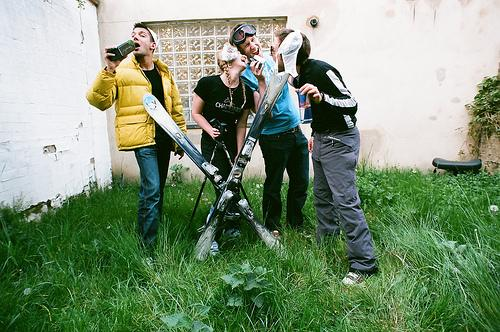List two clothing items that a man is wearing in the image, along with the color of the items. A man is wearing a blue shirt and gray pants. For the multi-choice VQA task, create a question and provide the correct answer among several choices. Correct Answer: b) Skiing Identify one object in the image and describe its position relative to another object. A long ski pole is positioned in front of a glass window in the image. What is a detail that distinguishes the surface in the image? The surface in the image is covered in tall green grass and appears overgrown. Describe a woman in the image, her appearance and her actions. A woman with long braided hair, wearing blue jeans and a black shirt, is seen laughing with her head to the side. Provide a description of the scene in the image involving people, their actions, and their environment. A group of people are standing on a grassy area with tall green grass, some are wearing ski gear, others are laughing and chatting, while a woman with braided hair is holding ski poles crossed behind skis in an 'x' formation. Write a sentence describing the man who is holding a particular beverage. The man holding a red bull in the image is also wearing a black sweater and is standing on the grassy area. Write a short advertisement text based on objects and people's actions present in the image. Discover the joy of skiing with friends! With our ski packages, you can have fun, laugh, and create unforgettable memories on the slopes. Be prepared with your goggles, poles, and good company! For the visual entailment task, write a statement that can be inferred from the image. It can be inferred that the people in the image are preparing for or just finished a skiing activity. Mention one activity that a man is doing in the image and his clothes' color. A man in a blue shirt is drinking from a bottle held up to his open mouth. 